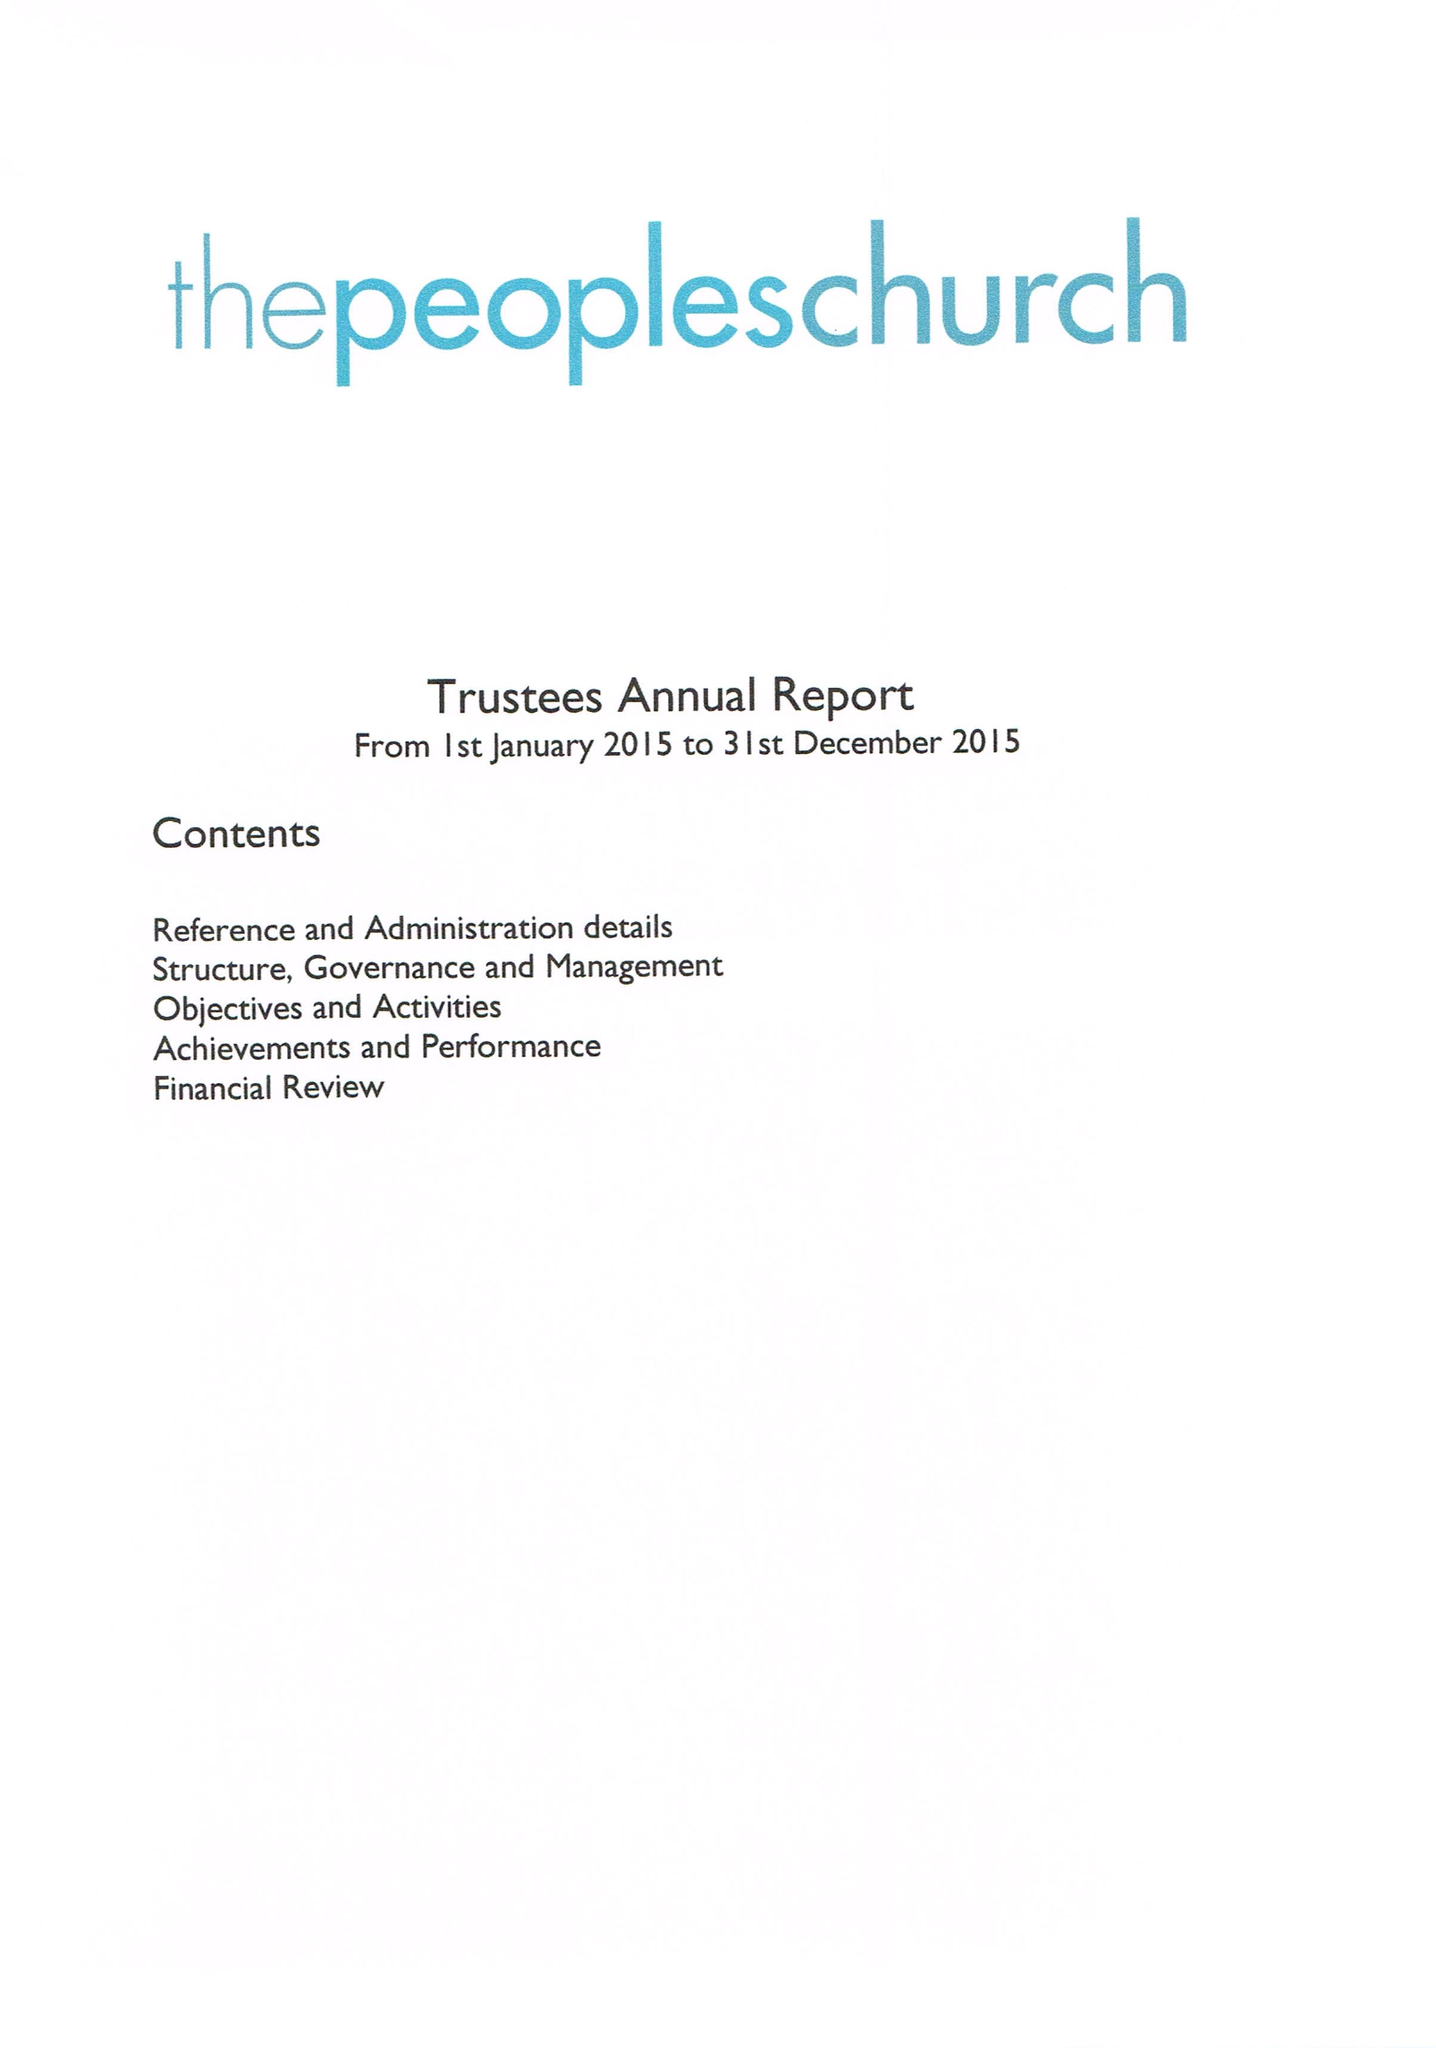What is the value for the address__street_line?
Answer the question using a single word or phrase. HORSE FAIR 